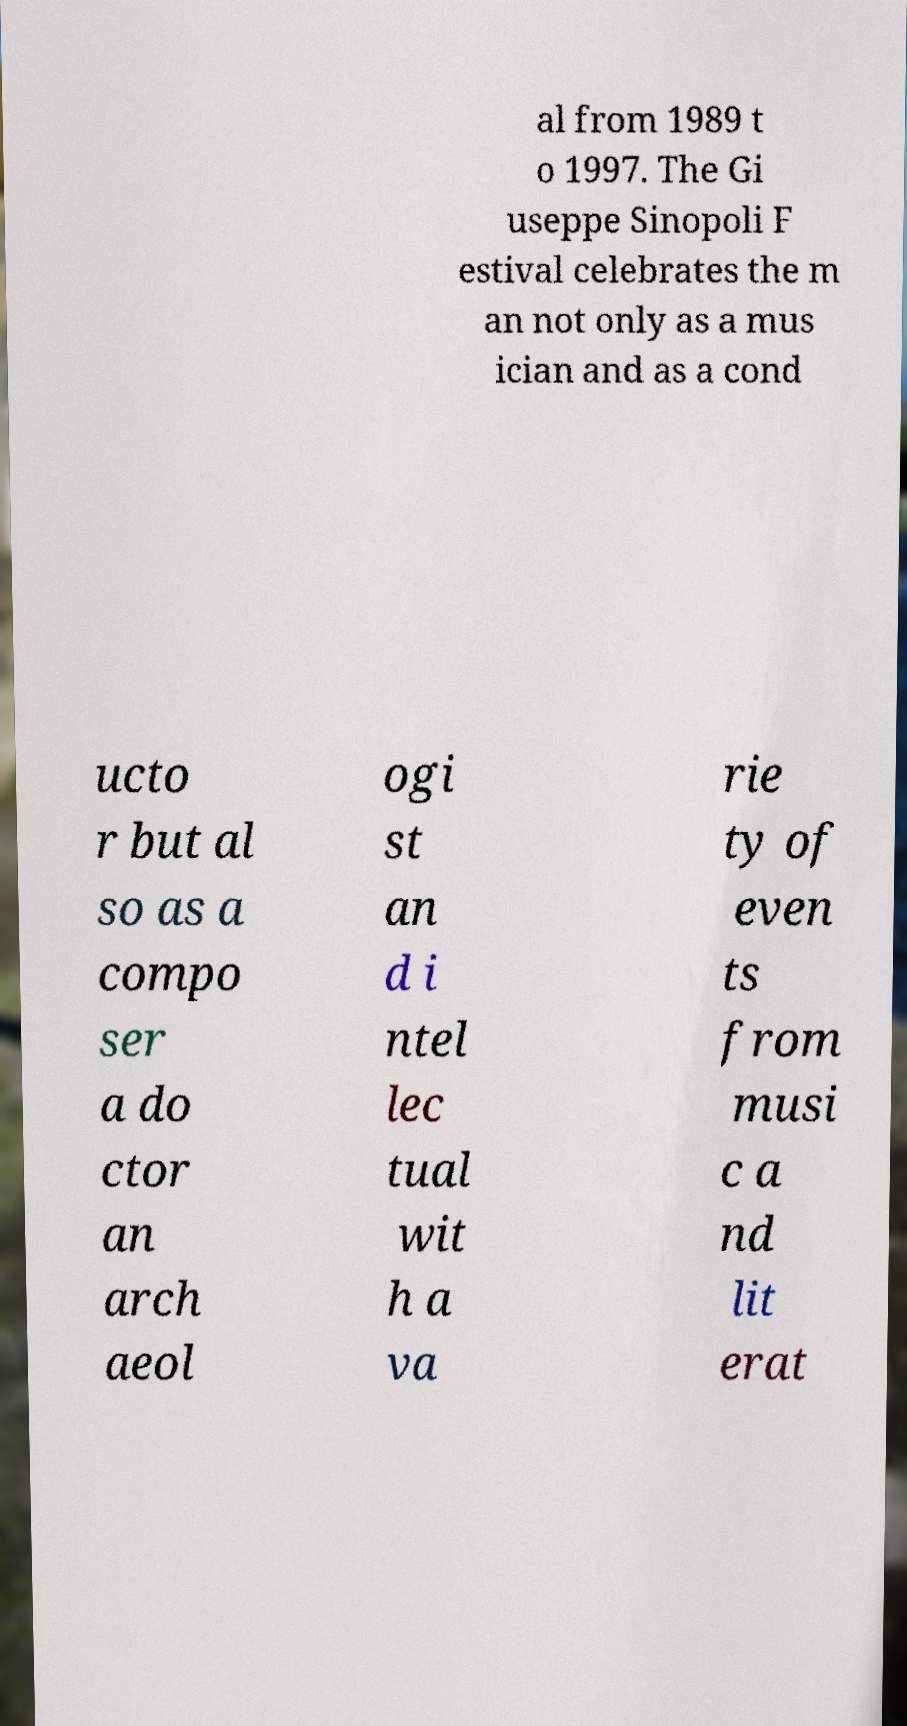Can you read and provide the text displayed in the image?This photo seems to have some interesting text. Can you extract and type it out for me? al from 1989 t o 1997. The Gi useppe Sinopoli F estival celebrates the m an not only as a mus ician and as a cond ucto r but al so as a compo ser a do ctor an arch aeol ogi st an d i ntel lec tual wit h a va rie ty of even ts from musi c a nd lit erat 